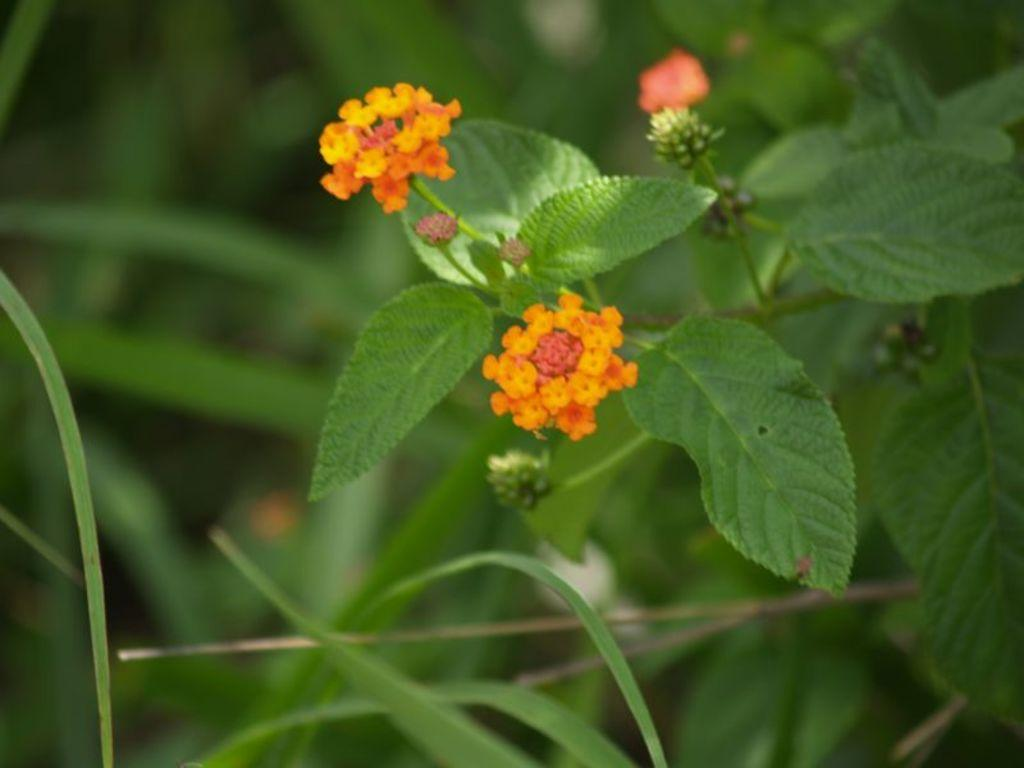What type of flora can be seen in the image? There are flowers in the image. What is the color of the flowers? The flowers are orange in color. What other part of the plants is visible in the image? There are green leaves in the image. What can be seen in the background of the image? There are plants in the background of the image. What month is it in the image? The month cannot be determined from the image, as it only shows flowers, leaves, and plants. Can you tell me how many times the flowers sneeze in the image? Flowers do not have the ability to sneeze, so this cannot be observed in the image. 